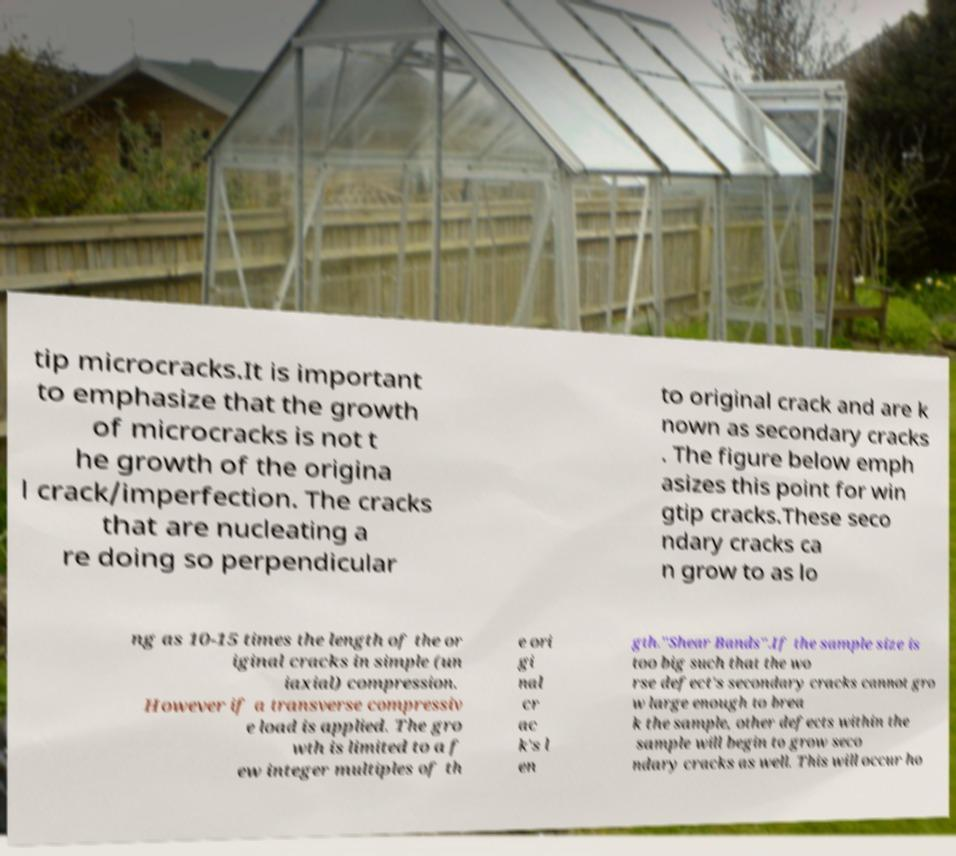Could you assist in decoding the text presented in this image and type it out clearly? tip microcracks.It is important to emphasize that the growth of microcracks is not t he growth of the origina l crack/imperfection. The cracks that are nucleating a re doing so perpendicular to original crack and are k nown as secondary cracks . The figure below emph asizes this point for win gtip cracks.These seco ndary cracks ca n grow to as lo ng as 10-15 times the length of the or iginal cracks in simple (un iaxial) compression. However if a transverse compressiv e load is applied. The gro wth is limited to a f ew integer multiples of th e ori gi nal cr ac k's l en gth."Shear Bands".If the sample size is too big such that the wo rse defect's secondary cracks cannot gro w large enough to brea k the sample, other defects within the sample will begin to grow seco ndary cracks as well. This will occur ho 